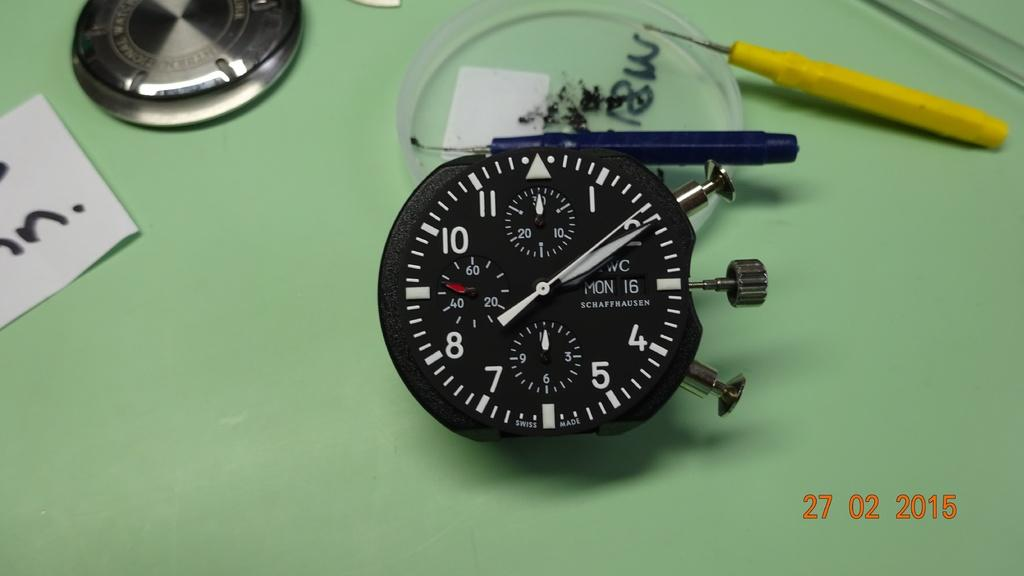<image>
Give a short and clear explanation of the subsequent image. A Schaffhausen watch is in pieces on a table. 